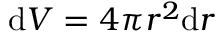Convert formula to latex. <formula><loc_0><loc_0><loc_500><loc_500>d V = 4 \pi r ^ { 2 } d r</formula> 